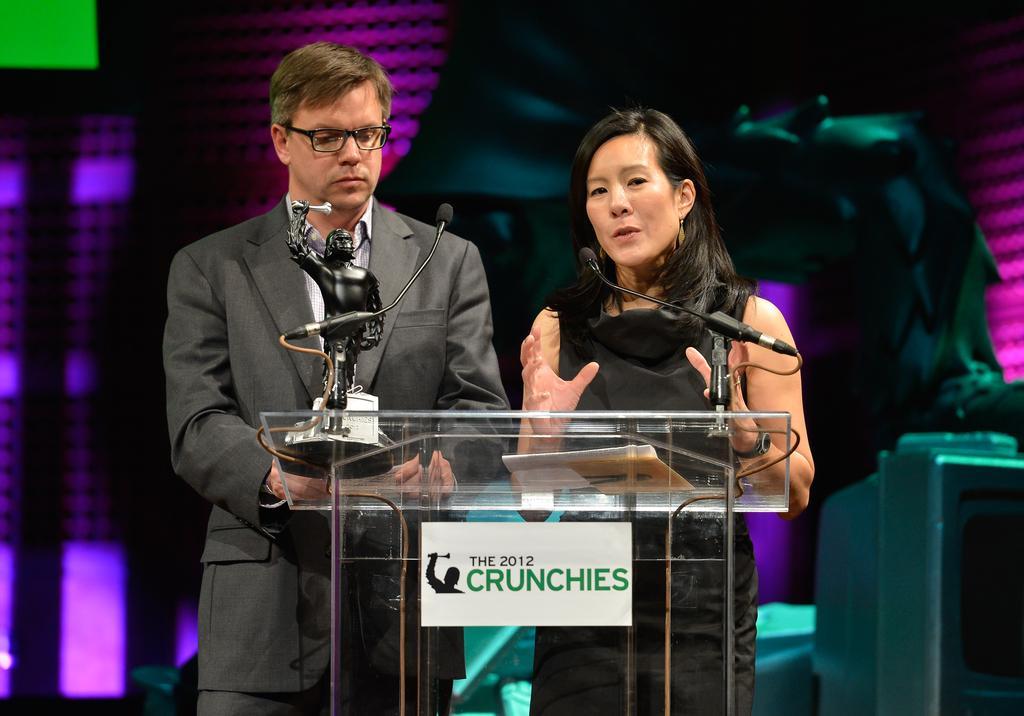How would you summarize this image in a sentence or two? In this image a man and a woman is standing behind the podium. In front of them there are mice, trophy. The lady is talking. In the background there are lights. 